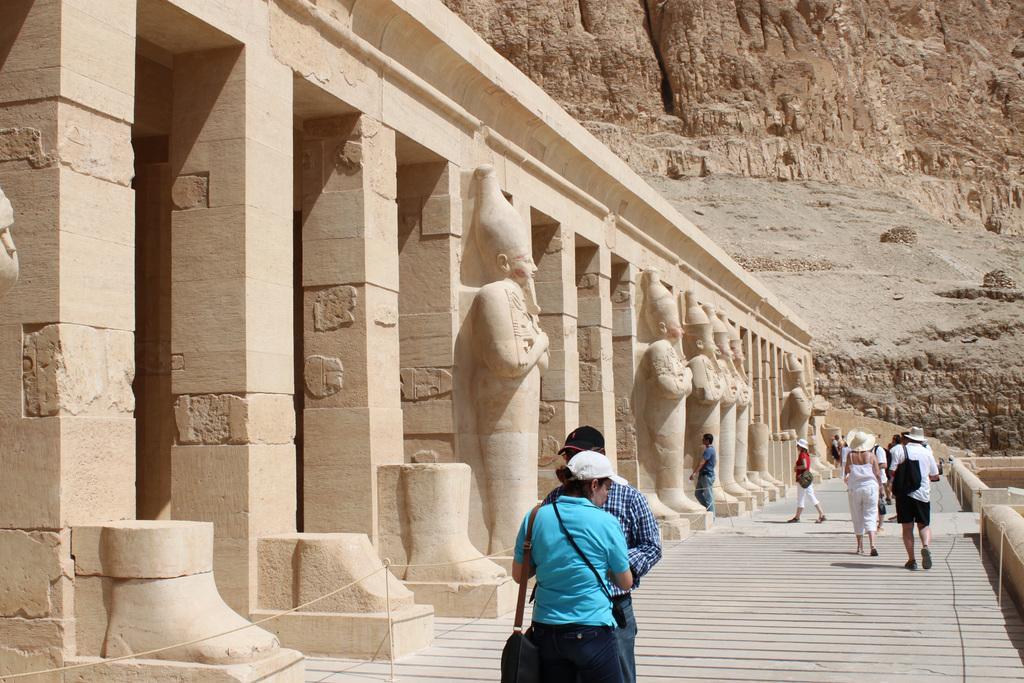Please provide a concise description of this image. This image consists of many people. It looks like a historic place. In the front, we can see many pillars and sculptures. On the right, there is a mountain. 